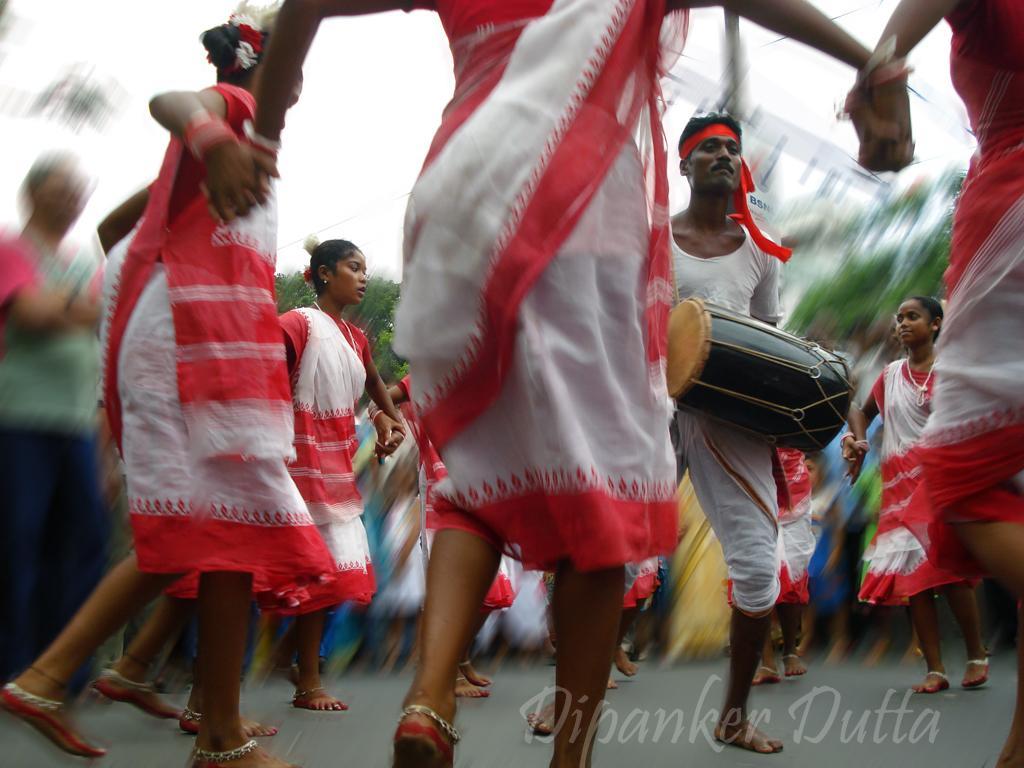Can you describe this image briefly? In this picture we can see a group of people dancing and in middle man playing drum and in background we can see sky, trees and it is blurry. 